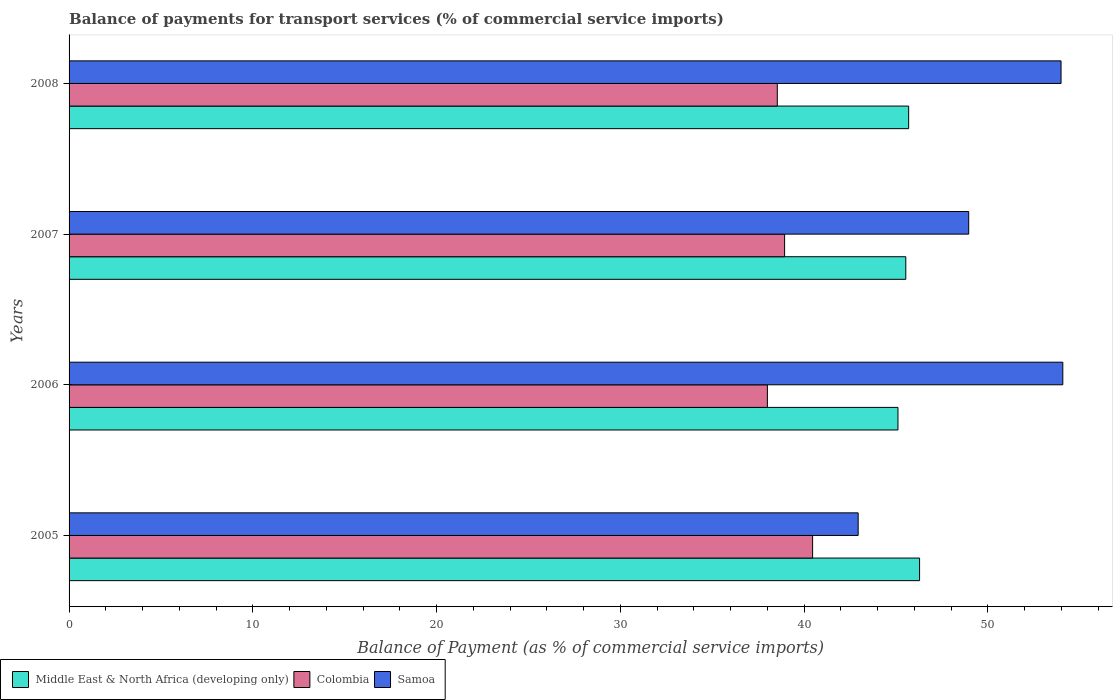How many different coloured bars are there?
Your answer should be compact. 3. How many groups of bars are there?
Your answer should be compact. 4. Are the number of bars per tick equal to the number of legend labels?
Give a very brief answer. Yes. How many bars are there on the 4th tick from the top?
Keep it short and to the point. 3. How many bars are there on the 2nd tick from the bottom?
Your answer should be very brief. 3. What is the label of the 2nd group of bars from the top?
Provide a succinct answer. 2007. In how many cases, is the number of bars for a given year not equal to the number of legend labels?
Your answer should be compact. 0. What is the balance of payments for transport services in Colombia in 2008?
Give a very brief answer. 38.54. Across all years, what is the maximum balance of payments for transport services in Samoa?
Give a very brief answer. 54.08. Across all years, what is the minimum balance of payments for transport services in Samoa?
Give a very brief answer. 42.94. In which year was the balance of payments for transport services in Middle East & North Africa (developing only) maximum?
Your response must be concise. 2005. What is the total balance of payments for transport services in Middle East & North Africa (developing only) in the graph?
Keep it short and to the point. 182.61. What is the difference between the balance of payments for transport services in Samoa in 2006 and that in 2008?
Offer a terse response. 0.1. What is the difference between the balance of payments for transport services in Middle East & North Africa (developing only) in 2006 and the balance of payments for transport services in Colombia in 2008?
Keep it short and to the point. 6.57. What is the average balance of payments for transport services in Colombia per year?
Ensure brevity in your answer.  38.99. In the year 2005, what is the difference between the balance of payments for transport services in Middle East & North Africa (developing only) and balance of payments for transport services in Colombia?
Make the answer very short. 5.82. In how many years, is the balance of payments for transport services in Colombia greater than 36 %?
Your answer should be compact. 4. What is the ratio of the balance of payments for transport services in Samoa in 2005 to that in 2006?
Make the answer very short. 0.79. What is the difference between the highest and the second highest balance of payments for transport services in Samoa?
Make the answer very short. 0.1. What is the difference between the highest and the lowest balance of payments for transport services in Middle East & North Africa (developing only)?
Give a very brief answer. 1.18. In how many years, is the balance of payments for transport services in Samoa greater than the average balance of payments for transport services in Samoa taken over all years?
Offer a very short reply. 2. Is the sum of the balance of payments for transport services in Samoa in 2005 and 2007 greater than the maximum balance of payments for transport services in Middle East & North Africa (developing only) across all years?
Ensure brevity in your answer.  Yes. What does the 2nd bar from the top in 2006 represents?
Ensure brevity in your answer.  Colombia. What does the 3rd bar from the bottom in 2005 represents?
Provide a short and direct response. Samoa. Is it the case that in every year, the sum of the balance of payments for transport services in Colombia and balance of payments for transport services in Middle East & North Africa (developing only) is greater than the balance of payments for transport services in Samoa?
Provide a short and direct response. Yes. How many bars are there?
Offer a very short reply. 12. How many years are there in the graph?
Make the answer very short. 4. What is the difference between two consecutive major ticks on the X-axis?
Offer a very short reply. 10. Does the graph contain any zero values?
Your answer should be compact. No. Does the graph contain grids?
Your answer should be compact. No. Where does the legend appear in the graph?
Make the answer very short. Bottom left. How many legend labels are there?
Give a very brief answer. 3. How are the legend labels stacked?
Provide a short and direct response. Horizontal. What is the title of the graph?
Provide a succinct answer. Balance of payments for transport services (% of commercial service imports). What is the label or title of the X-axis?
Make the answer very short. Balance of Payment (as % of commercial service imports). What is the Balance of Payment (as % of commercial service imports) in Middle East & North Africa (developing only) in 2005?
Keep it short and to the point. 46.28. What is the Balance of Payment (as % of commercial service imports) of Colombia in 2005?
Make the answer very short. 40.46. What is the Balance of Payment (as % of commercial service imports) of Samoa in 2005?
Your answer should be compact. 42.94. What is the Balance of Payment (as % of commercial service imports) of Middle East & North Africa (developing only) in 2006?
Your response must be concise. 45.11. What is the Balance of Payment (as % of commercial service imports) of Colombia in 2006?
Offer a very short reply. 38. What is the Balance of Payment (as % of commercial service imports) in Samoa in 2006?
Offer a terse response. 54.08. What is the Balance of Payment (as % of commercial service imports) of Middle East & North Africa (developing only) in 2007?
Give a very brief answer. 45.53. What is the Balance of Payment (as % of commercial service imports) of Colombia in 2007?
Provide a short and direct response. 38.94. What is the Balance of Payment (as % of commercial service imports) in Samoa in 2007?
Your response must be concise. 48.96. What is the Balance of Payment (as % of commercial service imports) of Middle East & North Africa (developing only) in 2008?
Your answer should be compact. 45.69. What is the Balance of Payment (as % of commercial service imports) of Colombia in 2008?
Keep it short and to the point. 38.54. What is the Balance of Payment (as % of commercial service imports) in Samoa in 2008?
Provide a succinct answer. 53.98. Across all years, what is the maximum Balance of Payment (as % of commercial service imports) of Middle East & North Africa (developing only)?
Your answer should be compact. 46.28. Across all years, what is the maximum Balance of Payment (as % of commercial service imports) in Colombia?
Your answer should be very brief. 40.46. Across all years, what is the maximum Balance of Payment (as % of commercial service imports) in Samoa?
Offer a terse response. 54.08. Across all years, what is the minimum Balance of Payment (as % of commercial service imports) of Middle East & North Africa (developing only)?
Your answer should be very brief. 45.11. Across all years, what is the minimum Balance of Payment (as % of commercial service imports) in Colombia?
Your answer should be very brief. 38. Across all years, what is the minimum Balance of Payment (as % of commercial service imports) in Samoa?
Make the answer very short. 42.94. What is the total Balance of Payment (as % of commercial service imports) of Middle East & North Africa (developing only) in the graph?
Your answer should be compact. 182.61. What is the total Balance of Payment (as % of commercial service imports) of Colombia in the graph?
Your answer should be compact. 155.94. What is the total Balance of Payment (as % of commercial service imports) of Samoa in the graph?
Provide a short and direct response. 199.95. What is the difference between the Balance of Payment (as % of commercial service imports) of Middle East & North Africa (developing only) in 2005 and that in 2006?
Give a very brief answer. 1.18. What is the difference between the Balance of Payment (as % of commercial service imports) in Colombia in 2005 and that in 2006?
Give a very brief answer. 2.46. What is the difference between the Balance of Payment (as % of commercial service imports) of Samoa in 2005 and that in 2006?
Give a very brief answer. -11.14. What is the difference between the Balance of Payment (as % of commercial service imports) of Middle East & North Africa (developing only) in 2005 and that in 2007?
Provide a short and direct response. 0.75. What is the difference between the Balance of Payment (as % of commercial service imports) of Colombia in 2005 and that in 2007?
Your response must be concise. 1.52. What is the difference between the Balance of Payment (as % of commercial service imports) of Samoa in 2005 and that in 2007?
Offer a terse response. -6.02. What is the difference between the Balance of Payment (as % of commercial service imports) of Middle East & North Africa (developing only) in 2005 and that in 2008?
Your answer should be compact. 0.59. What is the difference between the Balance of Payment (as % of commercial service imports) in Colombia in 2005 and that in 2008?
Offer a very short reply. 1.92. What is the difference between the Balance of Payment (as % of commercial service imports) of Samoa in 2005 and that in 2008?
Provide a succinct answer. -11.04. What is the difference between the Balance of Payment (as % of commercial service imports) in Middle East & North Africa (developing only) in 2006 and that in 2007?
Make the answer very short. -0.43. What is the difference between the Balance of Payment (as % of commercial service imports) in Colombia in 2006 and that in 2007?
Ensure brevity in your answer.  -0.94. What is the difference between the Balance of Payment (as % of commercial service imports) of Samoa in 2006 and that in 2007?
Make the answer very short. 5.12. What is the difference between the Balance of Payment (as % of commercial service imports) in Middle East & North Africa (developing only) in 2006 and that in 2008?
Your answer should be very brief. -0.58. What is the difference between the Balance of Payment (as % of commercial service imports) in Colombia in 2006 and that in 2008?
Provide a succinct answer. -0.54. What is the difference between the Balance of Payment (as % of commercial service imports) in Samoa in 2006 and that in 2008?
Offer a very short reply. 0.1. What is the difference between the Balance of Payment (as % of commercial service imports) in Middle East & North Africa (developing only) in 2007 and that in 2008?
Your answer should be compact. -0.16. What is the difference between the Balance of Payment (as % of commercial service imports) of Colombia in 2007 and that in 2008?
Give a very brief answer. 0.4. What is the difference between the Balance of Payment (as % of commercial service imports) in Samoa in 2007 and that in 2008?
Make the answer very short. -5.03. What is the difference between the Balance of Payment (as % of commercial service imports) in Middle East & North Africa (developing only) in 2005 and the Balance of Payment (as % of commercial service imports) in Colombia in 2006?
Make the answer very short. 8.28. What is the difference between the Balance of Payment (as % of commercial service imports) of Middle East & North Africa (developing only) in 2005 and the Balance of Payment (as % of commercial service imports) of Samoa in 2006?
Give a very brief answer. -7.79. What is the difference between the Balance of Payment (as % of commercial service imports) in Colombia in 2005 and the Balance of Payment (as % of commercial service imports) in Samoa in 2006?
Make the answer very short. -13.61. What is the difference between the Balance of Payment (as % of commercial service imports) in Middle East & North Africa (developing only) in 2005 and the Balance of Payment (as % of commercial service imports) in Colombia in 2007?
Offer a terse response. 7.34. What is the difference between the Balance of Payment (as % of commercial service imports) of Middle East & North Africa (developing only) in 2005 and the Balance of Payment (as % of commercial service imports) of Samoa in 2007?
Your response must be concise. -2.67. What is the difference between the Balance of Payment (as % of commercial service imports) of Colombia in 2005 and the Balance of Payment (as % of commercial service imports) of Samoa in 2007?
Your answer should be very brief. -8.49. What is the difference between the Balance of Payment (as % of commercial service imports) of Middle East & North Africa (developing only) in 2005 and the Balance of Payment (as % of commercial service imports) of Colombia in 2008?
Your answer should be very brief. 7.74. What is the difference between the Balance of Payment (as % of commercial service imports) in Middle East & North Africa (developing only) in 2005 and the Balance of Payment (as % of commercial service imports) in Samoa in 2008?
Provide a succinct answer. -7.7. What is the difference between the Balance of Payment (as % of commercial service imports) in Colombia in 2005 and the Balance of Payment (as % of commercial service imports) in Samoa in 2008?
Provide a succinct answer. -13.52. What is the difference between the Balance of Payment (as % of commercial service imports) in Middle East & North Africa (developing only) in 2006 and the Balance of Payment (as % of commercial service imports) in Colombia in 2007?
Provide a short and direct response. 6.17. What is the difference between the Balance of Payment (as % of commercial service imports) of Middle East & North Africa (developing only) in 2006 and the Balance of Payment (as % of commercial service imports) of Samoa in 2007?
Your answer should be compact. -3.85. What is the difference between the Balance of Payment (as % of commercial service imports) in Colombia in 2006 and the Balance of Payment (as % of commercial service imports) in Samoa in 2007?
Ensure brevity in your answer.  -10.95. What is the difference between the Balance of Payment (as % of commercial service imports) in Middle East & North Africa (developing only) in 2006 and the Balance of Payment (as % of commercial service imports) in Colombia in 2008?
Your answer should be very brief. 6.57. What is the difference between the Balance of Payment (as % of commercial service imports) in Middle East & North Africa (developing only) in 2006 and the Balance of Payment (as % of commercial service imports) in Samoa in 2008?
Your response must be concise. -8.87. What is the difference between the Balance of Payment (as % of commercial service imports) of Colombia in 2006 and the Balance of Payment (as % of commercial service imports) of Samoa in 2008?
Your answer should be compact. -15.98. What is the difference between the Balance of Payment (as % of commercial service imports) in Middle East & North Africa (developing only) in 2007 and the Balance of Payment (as % of commercial service imports) in Colombia in 2008?
Your answer should be compact. 6.99. What is the difference between the Balance of Payment (as % of commercial service imports) in Middle East & North Africa (developing only) in 2007 and the Balance of Payment (as % of commercial service imports) in Samoa in 2008?
Your answer should be very brief. -8.45. What is the difference between the Balance of Payment (as % of commercial service imports) in Colombia in 2007 and the Balance of Payment (as % of commercial service imports) in Samoa in 2008?
Your answer should be compact. -15.04. What is the average Balance of Payment (as % of commercial service imports) of Middle East & North Africa (developing only) per year?
Your answer should be very brief. 45.65. What is the average Balance of Payment (as % of commercial service imports) of Colombia per year?
Offer a terse response. 38.99. What is the average Balance of Payment (as % of commercial service imports) of Samoa per year?
Provide a short and direct response. 49.99. In the year 2005, what is the difference between the Balance of Payment (as % of commercial service imports) in Middle East & North Africa (developing only) and Balance of Payment (as % of commercial service imports) in Colombia?
Your response must be concise. 5.82. In the year 2005, what is the difference between the Balance of Payment (as % of commercial service imports) in Middle East & North Africa (developing only) and Balance of Payment (as % of commercial service imports) in Samoa?
Provide a succinct answer. 3.34. In the year 2005, what is the difference between the Balance of Payment (as % of commercial service imports) in Colombia and Balance of Payment (as % of commercial service imports) in Samoa?
Ensure brevity in your answer.  -2.48. In the year 2006, what is the difference between the Balance of Payment (as % of commercial service imports) of Middle East & North Africa (developing only) and Balance of Payment (as % of commercial service imports) of Colombia?
Your answer should be compact. 7.11. In the year 2006, what is the difference between the Balance of Payment (as % of commercial service imports) of Middle East & North Africa (developing only) and Balance of Payment (as % of commercial service imports) of Samoa?
Keep it short and to the point. -8.97. In the year 2006, what is the difference between the Balance of Payment (as % of commercial service imports) of Colombia and Balance of Payment (as % of commercial service imports) of Samoa?
Make the answer very short. -16.08. In the year 2007, what is the difference between the Balance of Payment (as % of commercial service imports) of Middle East & North Africa (developing only) and Balance of Payment (as % of commercial service imports) of Colombia?
Keep it short and to the point. 6.59. In the year 2007, what is the difference between the Balance of Payment (as % of commercial service imports) in Middle East & North Africa (developing only) and Balance of Payment (as % of commercial service imports) in Samoa?
Give a very brief answer. -3.42. In the year 2007, what is the difference between the Balance of Payment (as % of commercial service imports) of Colombia and Balance of Payment (as % of commercial service imports) of Samoa?
Keep it short and to the point. -10.02. In the year 2008, what is the difference between the Balance of Payment (as % of commercial service imports) of Middle East & North Africa (developing only) and Balance of Payment (as % of commercial service imports) of Colombia?
Your answer should be very brief. 7.15. In the year 2008, what is the difference between the Balance of Payment (as % of commercial service imports) in Middle East & North Africa (developing only) and Balance of Payment (as % of commercial service imports) in Samoa?
Provide a succinct answer. -8.29. In the year 2008, what is the difference between the Balance of Payment (as % of commercial service imports) of Colombia and Balance of Payment (as % of commercial service imports) of Samoa?
Your answer should be compact. -15.44. What is the ratio of the Balance of Payment (as % of commercial service imports) in Middle East & North Africa (developing only) in 2005 to that in 2006?
Make the answer very short. 1.03. What is the ratio of the Balance of Payment (as % of commercial service imports) of Colombia in 2005 to that in 2006?
Your answer should be compact. 1.06. What is the ratio of the Balance of Payment (as % of commercial service imports) in Samoa in 2005 to that in 2006?
Keep it short and to the point. 0.79. What is the ratio of the Balance of Payment (as % of commercial service imports) of Middle East & North Africa (developing only) in 2005 to that in 2007?
Provide a short and direct response. 1.02. What is the ratio of the Balance of Payment (as % of commercial service imports) in Colombia in 2005 to that in 2007?
Give a very brief answer. 1.04. What is the ratio of the Balance of Payment (as % of commercial service imports) of Samoa in 2005 to that in 2007?
Your answer should be compact. 0.88. What is the ratio of the Balance of Payment (as % of commercial service imports) in Middle East & North Africa (developing only) in 2005 to that in 2008?
Give a very brief answer. 1.01. What is the ratio of the Balance of Payment (as % of commercial service imports) of Colombia in 2005 to that in 2008?
Your response must be concise. 1.05. What is the ratio of the Balance of Payment (as % of commercial service imports) in Samoa in 2005 to that in 2008?
Provide a succinct answer. 0.8. What is the ratio of the Balance of Payment (as % of commercial service imports) in Colombia in 2006 to that in 2007?
Your response must be concise. 0.98. What is the ratio of the Balance of Payment (as % of commercial service imports) of Samoa in 2006 to that in 2007?
Your answer should be compact. 1.1. What is the ratio of the Balance of Payment (as % of commercial service imports) in Middle East & North Africa (developing only) in 2006 to that in 2008?
Provide a succinct answer. 0.99. What is the ratio of the Balance of Payment (as % of commercial service imports) of Colombia in 2007 to that in 2008?
Offer a terse response. 1.01. What is the ratio of the Balance of Payment (as % of commercial service imports) of Samoa in 2007 to that in 2008?
Your answer should be compact. 0.91. What is the difference between the highest and the second highest Balance of Payment (as % of commercial service imports) of Middle East & North Africa (developing only)?
Make the answer very short. 0.59. What is the difference between the highest and the second highest Balance of Payment (as % of commercial service imports) of Colombia?
Your answer should be compact. 1.52. What is the difference between the highest and the second highest Balance of Payment (as % of commercial service imports) in Samoa?
Provide a succinct answer. 0.1. What is the difference between the highest and the lowest Balance of Payment (as % of commercial service imports) of Middle East & North Africa (developing only)?
Your answer should be very brief. 1.18. What is the difference between the highest and the lowest Balance of Payment (as % of commercial service imports) of Colombia?
Keep it short and to the point. 2.46. What is the difference between the highest and the lowest Balance of Payment (as % of commercial service imports) in Samoa?
Provide a short and direct response. 11.14. 